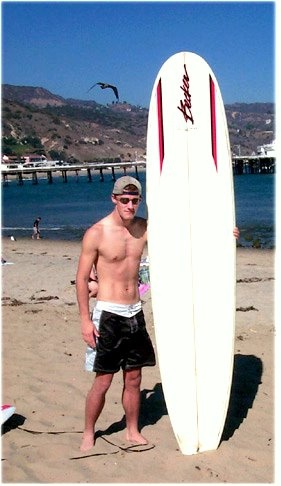Describe the objects in this image and their specific colors. I can see surfboard in beige, white, brown, black, and gray tones, people in beige, salmon, black, brown, and maroon tones, people in beige, black, gray, and darkgray tones, bird in beige, black, navy, and blue tones, and bird in beige, white, darkgray, and gray tones in this image. 